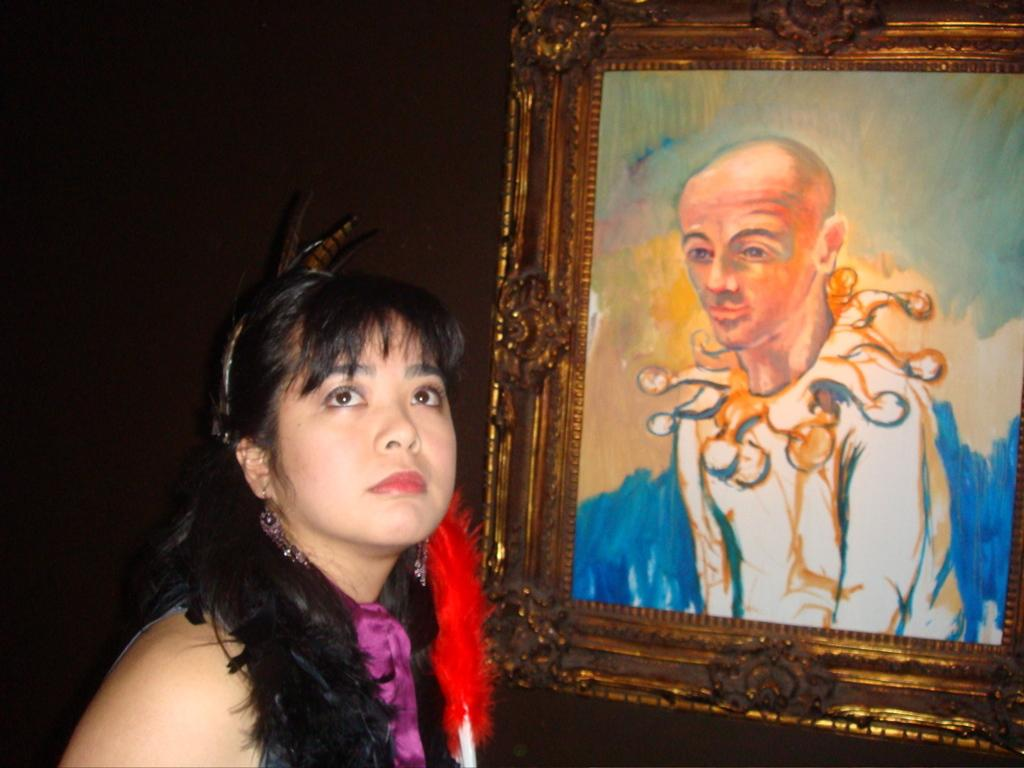Who is present in the image? There is a woman in the image. What object can be seen in the image besides the woman? There is a photo frame in the image. Can you describe the background of the image? The background of the image is dark. What type of jelly is being used to decorate the photo frame in the image? There is no jelly present in the image, and the photo frame is not being decorated with any jelly. 